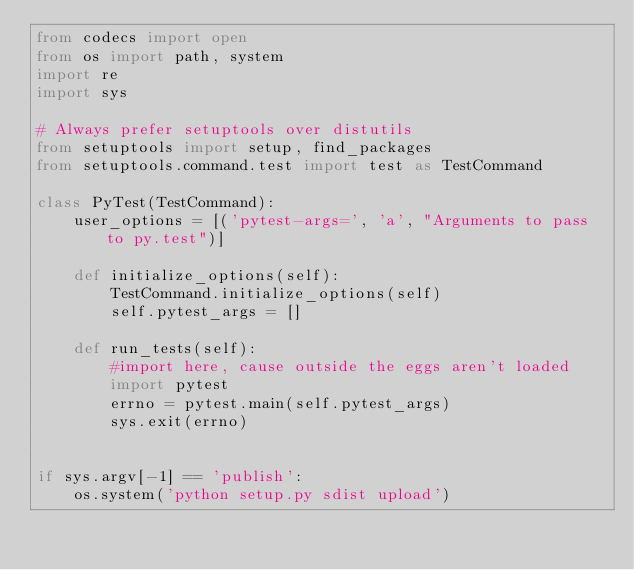<code> <loc_0><loc_0><loc_500><loc_500><_Python_>from codecs import open
from os import path, system
import re
import sys

# Always prefer setuptools over distutils
from setuptools import setup, find_packages
from setuptools.command.test import test as TestCommand

class PyTest(TestCommand):
    user_options = [('pytest-args=', 'a', "Arguments to pass to py.test")]

    def initialize_options(self):
        TestCommand.initialize_options(self)
        self.pytest_args = []

    def run_tests(self):
        #import here, cause outside the eggs aren't loaded
        import pytest
        errno = pytest.main(self.pytest_args)
        sys.exit(errno)


if sys.argv[-1] == 'publish':
    os.system('python setup.py sdist upload')</code> 